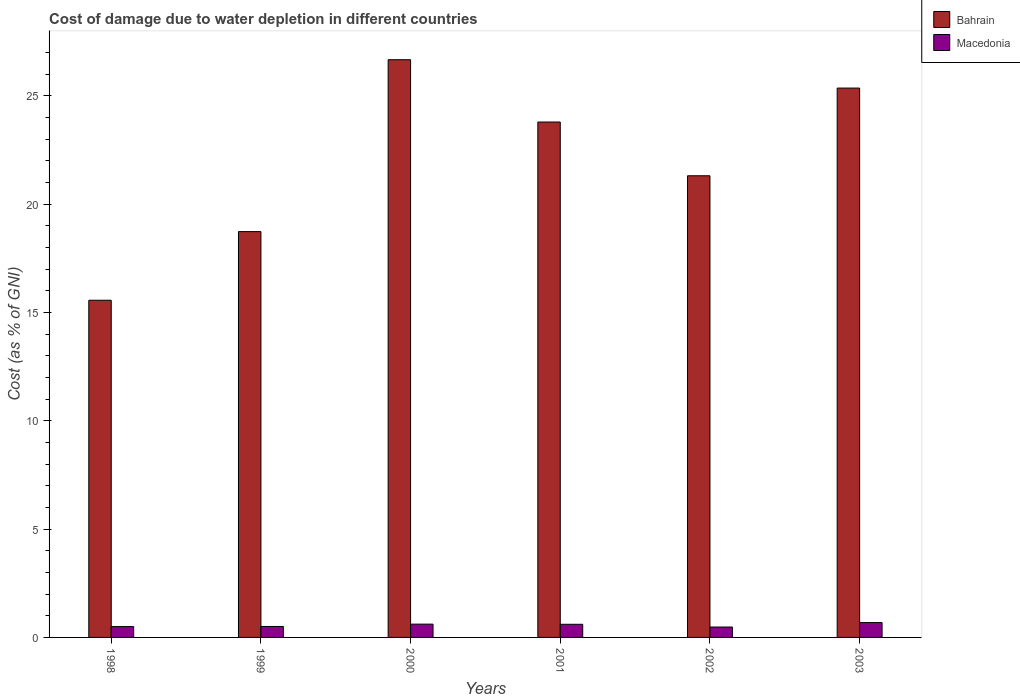How many different coloured bars are there?
Provide a succinct answer. 2. What is the label of the 6th group of bars from the left?
Offer a very short reply. 2003. What is the cost of damage caused due to water depletion in Macedonia in 2001?
Ensure brevity in your answer.  0.61. Across all years, what is the maximum cost of damage caused due to water depletion in Bahrain?
Your answer should be very brief. 26.66. Across all years, what is the minimum cost of damage caused due to water depletion in Macedonia?
Your answer should be compact. 0.48. In which year was the cost of damage caused due to water depletion in Bahrain maximum?
Offer a terse response. 2000. In which year was the cost of damage caused due to water depletion in Bahrain minimum?
Your response must be concise. 1998. What is the total cost of damage caused due to water depletion in Bahrain in the graph?
Ensure brevity in your answer.  131.41. What is the difference between the cost of damage caused due to water depletion in Bahrain in 1998 and that in 2001?
Keep it short and to the point. -8.23. What is the difference between the cost of damage caused due to water depletion in Macedonia in 2000 and the cost of damage caused due to water depletion in Bahrain in 1998?
Keep it short and to the point. -14.95. What is the average cost of damage caused due to water depletion in Bahrain per year?
Provide a short and direct response. 21.9. In the year 2000, what is the difference between the cost of damage caused due to water depletion in Macedonia and cost of damage caused due to water depletion in Bahrain?
Your answer should be very brief. -26.05. What is the ratio of the cost of damage caused due to water depletion in Macedonia in 2000 to that in 2001?
Give a very brief answer. 1.01. Is the cost of damage caused due to water depletion in Macedonia in 2001 less than that in 2003?
Your answer should be very brief. Yes. What is the difference between the highest and the second highest cost of damage caused due to water depletion in Macedonia?
Your response must be concise. 0.07. What is the difference between the highest and the lowest cost of damage caused due to water depletion in Bahrain?
Make the answer very short. 11.1. In how many years, is the cost of damage caused due to water depletion in Bahrain greater than the average cost of damage caused due to water depletion in Bahrain taken over all years?
Keep it short and to the point. 3. Is the sum of the cost of damage caused due to water depletion in Bahrain in 1999 and 2003 greater than the maximum cost of damage caused due to water depletion in Macedonia across all years?
Your answer should be very brief. Yes. What does the 1st bar from the left in 1998 represents?
Give a very brief answer. Bahrain. What does the 1st bar from the right in 1999 represents?
Provide a succinct answer. Macedonia. Does the graph contain any zero values?
Offer a terse response. No. How are the legend labels stacked?
Make the answer very short. Vertical. What is the title of the graph?
Your answer should be compact. Cost of damage due to water depletion in different countries. Does "Costa Rica" appear as one of the legend labels in the graph?
Your response must be concise. No. What is the label or title of the X-axis?
Offer a terse response. Years. What is the label or title of the Y-axis?
Offer a terse response. Cost (as % of GNI). What is the Cost (as % of GNI) of Bahrain in 1998?
Provide a succinct answer. 15.56. What is the Cost (as % of GNI) in Macedonia in 1998?
Provide a succinct answer. 0.5. What is the Cost (as % of GNI) of Bahrain in 1999?
Offer a very short reply. 18.73. What is the Cost (as % of GNI) of Macedonia in 1999?
Make the answer very short. 0.51. What is the Cost (as % of GNI) of Bahrain in 2000?
Give a very brief answer. 26.66. What is the Cost (as % of GNI) in Macedonia in 2000?
Make the answer very short. 0.61. What is the Cost (as % of GNI) in Bahrain in 2001?
Your response must be concise. 23.79. What is the Cost (as % of GNI) in Macedonia in 2001?
Give a very brief answer. 0.61. What is the Cost (as % of GNI) of Bahrain in 2002?
Make the answer very short. 21.31. What is the Cost (as % of GNI) in Macedonia in 2002?
Keep it short and to the point. 0.48. What is the Cost (as % of GNI) of Bahrain in 2003?
Offer a terse response. 25.36. What is the Cost (as % of GNI) in Macedonia in 2003?
Your answer should be very brief. 0.69. Across all years, what is the maximum Cost (as % of GNI) of Bahrain?
Keep it short and to the point. 26.66. Across all years, what is the maximum Cost (as % of GNI) in Macedonia?
Provide a succinct answer. 0.69. Across all years, what is the minimum Cost (as % of GNI) in Bahrain?
Give a very brief answer. 15.56. Across all years, what is the minimum Cost (as % of GNI) of Macedonia?
Give a very brief answer. 0.48. What is the total Cost (as % of GNI) of Bahrain in the graph?
Keep it short and to the point. 131.41. What is the total Cost (as % of GNI) in Macedonia in the graph?
Keep it short and to the point. 3.39. What is the difference between the Cost (as % of GNI) of Bahrain in 1998 and that in 1999?
Offer a terse response. -3.17. What is the difference between the Cost (as % of GNI) of Macedonia in 1998 and that in 1999?
Your answer should be compact. -0.01. What is the difference between the Cost (as % of GNI) in Bahrain in 1998 and that in 2000?
Your answer should be compact. -11.1. What is the difference between the Cost (as % of GNI) in Macedonia in 1998 and that in 2000?
Provide a short and direct response. -0.11. What is the difference between the Cost (as % of GNI) of Bahrain in 1998 and that in 2001?
Provide a succinct answer. -8.23. What is the difference between the Cost (as % of GNI) of Macedonia in 1998 and that in 2001?
Provide a short and direct response. -0.11. What is the difference between the Cost (as % of GNI) in Bahrain in 1998 and that in 2002?
Make the answer very short. -5.75. What is the difference between the Cost (as % of GNI) in Macedonia in 1998 and that in 2002?
Your response must be concise. 0.02. What is the difference between the Cost (as % of GNI) in Bahrain in 1998 and that in 2003?
Offer a terse response. -9.79. What is the difference between the Cost (as % of GNI) in Macedonia in 1998 and that in 2003?
Your response must be concise. -0.18. What is the difference between the Cost (as % of GNI) of Bahrain in 1999 and that in 2000?
Your answer should be compact. -7.93. What is the difference between the Cost (as % of GNI) of Macedonia in 1999 and that in 2000?
Keep it short and to the point. -0.11. What is the difference between the Cost (as % of GNI) of Bahrain in 1999 and that in 2001?
Ensure brevity in your answer.  -5.06. What is the difference between the Cost (as % of GNI) of Macedonia in 1999 and that in 2001?
Ensure brevity in your answer.  -0.1. What is the difference between the Cost (as % of GNI) of Bahrain in 1999 and that in 2002?
Your response must be concise. -2.58. What is the difference between the Cost (as % of GNI) in Macedonia in 1999 and that in 2002?
Keep it short and to the point. 0.03. What is the difference between the Cost (as % of GNI) in Bahrain in 1999 and that in 2003?
Your response must be concise. -6.62. What is the difference between the Cost (as % of GNI) in Macedonia in 1999 and that in 2003?
Keep it short and to the point. -0.18. What is the difference between the Cost (as % of GNI) of Bahrain in 2000 and that in 2001?
Ensure brevity in your answer.  2.88. What is the difference between the Cost (as % of GNI) in Macedonia in 2000 and that in 2001?
Offer a terse response. 0.01. What is the difference between the Cost (as % of GNI) of Bahrain in 2000 and that in 2002?
Ensure brevity in your answer.  5.36. What is the difference between the Cost (as % of GNI) of Macedonia in 2000 and that in 2002?
Offer a very short reply. 0.13. What is the difference between the Cost (as % of GNI) of Bahrain in 2000 and that in 2003?
Offer a terse response. 1.31. What is the difference between the Cost (as % of GNI) of Macedonia in 2000 and that in 2003?
Provide a succinct answer. -0.07. What is the difference between the Cost (as % of GNI) of Bahrain in 2001 and that in 2002?
Offer a terse response. 2.48. What is the difference between the Cost (as % of GNI) in Macedonia in 2001 and that in 2002?
Make the answer very short. 0.13. What is the difference between the Cost (as % of GNI) of Bahrain in 2001 and that in 2003?
Give a very brief answer. -1.57. What is the difference between the Cost (as % of GNI) of Macedonia in 2001 and that in 2003?
Provide a succinct answer. -0.08. What is the difference between the Cost (as % of GNI) in Bahrain in 2002 and that in 2003?
Keep it short and to the point. -4.05. What is the difference between the Cost (as % of GNI) in Macedonia in 2002 and that in 2003?
Provide a succinct answer. -0.2. What is the difference between the Cost (as % of GNI) in Bahrain in 1998 and the Cost (as % of GNI) in Macedonia in 1999?
Make the answer very short. 15.06. What is the difference between the Cost (as % of GNI) of Bahrain in 1998 and the Cost (as % of GNI) of Macedonia in 2000?
Your answer should be very brief. 14.95. What is the difference between the Cost (as % of GNI) in Bahrain in 1998 and the Cost (as % of GNI) in Macedonia in 2001?
Ensure brevity in your answer.  14.96. What is the difference between the Cost (as % of GNI) of Bahrain in 1998 and the Cost (as % of GNI) of Macedonia in 2002?
Your answer should be compact. 15.08. What is the difference between the Cost (as % of GNI) of Bahrain in 1998 and the Cost (as % of GNI) of Macedonia in 2003?
Give a very brief answer. 14.88. What is the difference between the Cost (as % of GNI) in Bahrain in 1999 and the Cost (as % of GNI) in Macedonia in 2000?
Keep it short and to the point. 18.12. What is the difference between the Cost (as % of GNI) of Bahrain in 1999 and the Cost (as % of GNI) of Macedonia in 2001?
Ensure brevity in your answer.  18.12. What is the difference between the Cost (as % of GNI) in Bahrain in 1999 and the Cost (as % of GNI) in Macedonia in 2002?
Offer a terse response. 18.25. What is the difference between the Cost (as % of GNI) of Bahrain in 1999 and the Cost (as % of GNI) of Macedonia in 2003?
Give a very brief answer. 18.05. What is the difference between the Cost (as % of GNI) in Bahrain in 2000 and the Cost (as % of GNI) in Macedonia in 2001?
Provide a short and direct response. 26.06. What is the difference between the Cost (as % of GNI) of Bahrain in 2000 and the Cost (as % of GNI) of Macedonia in 2002?
Offer a very short reply. 26.18. What is the difference between the Cost (as % of GNI) in Bahrain in 2000 and the Cost (as % of GNI) in Macedonia in 2003?
Make the answer very short. 25.98. What is the difference between the Cost (as % of GNI) of Bahrain in 2001 and the Cost (as % of GNI) of Macedonia in 2002?
Offer a terse response. 23.31. What is the difference between the Cost (as % of GNI) in Bahrain in 2001 and the Cost (as % of GNI) in Macedonia in 2003?
Make the answer very short. 23.1. What is the difference between the Cost (as % of GNI) in Bahrain in 2002 and the Cost (as % of GNI) in Macedonia in 2003?
Your response must be concise. 20.62. What is the average Cost (as % of GNI) in Bahrain per year?
Provide a succinct answer. 21.9. What is the average Cost (as % of GNI) of Macedonia per year?
Offer a terse response. 0.57. In the year 1998, what is the difference between the Cost (as % of GNI) in Bahrain and Cost (as % of GNI) in Macedonia?
Offer a terse response. 15.06. In the year 1999, what is the difference between the Cost (as % of GNI) in Bahrain and Cost (as % of GNI) in Macedonia?
Provide a succinct answer. 18.22. In the year 2000, what is the difference between the Cost (as % of GNI) of Bahrain and Cost (as % of GNI) of Macedonia?
Make the answer very short. 26.05. In the year 2001, what is the difference between the Cost (as % of GNI) in Bahrain and Cost (as % of GNI) in Macedonia?
Ensure brevity in your answer.  23.18. In the year 2002, what is the difference between the Cost (as % of GNI) in Bahrain and Cost (as % of GNI) in Macedonia?
Provide a succinct answer. 20.83. In the year 2003, what is the difference between the Cost (as % of GNI) in Bahrain and Cost (as % of GNI) in Macedonia?
Your response must be concise. 24.67. What is the ratio of the Cost (as % of GNI) in Bahrain in 1998 to that in 1999?
Give a very brief answer. 0.83. What is the ratio of the Cost (as % of GNI) of Macedonia in 1998 to that in 1999?
Provide a succinct answer. 0.99. What is the ratio of the Cost (as % of GNI) of Bahrain in 1998 to that in 2000?
Provide a succinct answer. 0.58. What is the ratio of the Cost (as % of GNI) of Macedonia in 1998 to that in 2000?
Provide a short and direct response. 0.81. What is the ratio of the Cost (as % of GNI) of Bahrain in 1998 to that in 2001?
Give a very brief answer. 0.65. What is the ratio of the Cost (as % of GNI) in Macedonia in 1998 to that in 2001?
Your response must be concise. 0.82. What is the ratio of the Cost (as % of GNI) of Bahrain in 1998 to that in 2002?
Ensure brevity in your answer.  0.73. What is the ratio of the Cost (as % of GNI) of Macedonia in 1998 to that in 2002?
Make the answer very short. 1.04. What is the ratio of the Cost (as % of GNI) in Bahrain in 1998 to that in 2003?
Offer a very short reply. 0.61. What is the ratio of the Cost (as % of GNI) in Macedonia in 1998 to that in 2003?
Your answer should be very brief. 0.73. What is the ratio of the Cost (as % of GNI) of Bahrain in 1999 to that in 2000?
Offer a very short reply. 0.7. What is the ratio of the Cost (as % of GNI) in Macedonia in 1999 to that in 2000?
Your response must be concise. 0.82. What is the ratio of the Cost (as % of GNI) of Bahrain in 1999 to that in 2001?
Keep it short and to the point. 0.79. What is the ratio of the Cost (as % of GNI) of Macedonia in 1999 to that in 2001?
Keep it short and to the point. 0.83. What is the ratio of the Cost (as % of GNI) of Bahrain in 1999 to that in 2002?
Give a very brief answer. 0.88. What is the ratio of the Cost (as % of GNI) in Macedonia in 1999 to that in 2002?
Provide a succinct answer. 1.05. What is the ratio of the Cost (as % of GNI) of Bahrain in 1999 to that in 2003?
Give a very brief answer. 0.74. What is the ratio of the Cost (as % of GNI) of Macedonia in 1999 to that in 2003?
Ensure brevity in your answer.  0.74. What is the ratio of the Cost (as % of GNI) of Bahrain in 2000 to that in 2001?
Keep it short and to the point. 1.12. What is the ratio of the Cost (as % of GNI) in Macedonia in 2000 to that in 2001?
Give a very brief answer. 1.01. What is the ratio of the Cost (as % of GNI) in Bahrain in 2000 to that in 2002?
Provide a succinct answer. 1.25. What is the ratio of the Cost (as % of GNI) of Macedonia in 2000 to that in 2002?
Make the answer very short. 1.28. What is the ratio of the Cost (as % of GNI) in Bahrain in 2000 to that in 2003?
Keep it short and to the point. 1.05. What is the ratio of the Cost (as % of GNI) in Macedonia in 2000 to that in 2003?
Offer a terse response. 0.9. What is the ratio of the Cost (as % of GNI) of Bahrain in 2001 to that in 2002?
Give a very brief answer. 1.12. What is the ratio of the Cost (as % of GNI) in Macedonia in 2001 to that in 2002?
Give a very brief answer. 1.26. What is the ratio of the Cost (as % of GNI) in Bahrain in 2001 to that in 2003?
Keep it short and to the point. 0.94. What is the ratio of the Cost (as % of GNI) in Macedonia in 2001 to that in 2003?
Offer a very short reply. 0.89. What is the ratio of the Cost (as % of GNI) in Bahrain in 2002 to that in 2003?
Provide a short and direct response. 0.84. What is the ratio of the Cost (as % of GNI) in Macedonia in 2002 to that in 2003?
Offer a very short reply. 0.7. What is the difference between the highest and the second highest Cost (as % of GNI) in Bahrain?
Make the answer very short. 1.31. What is the difference between the highest and the second highest Cost (as % of GNI) of Macedonia?
Your answer should be very brief. 0.07. What is the difference between the highest and the lowest Cost (as % of GNI) of Bahrain?
Make the answer very short. 11.1. What is the difference between the highest and the lowest Cost (as % of GNI) in Macedonia?
Ensure brevity in your answer.  0.2. 